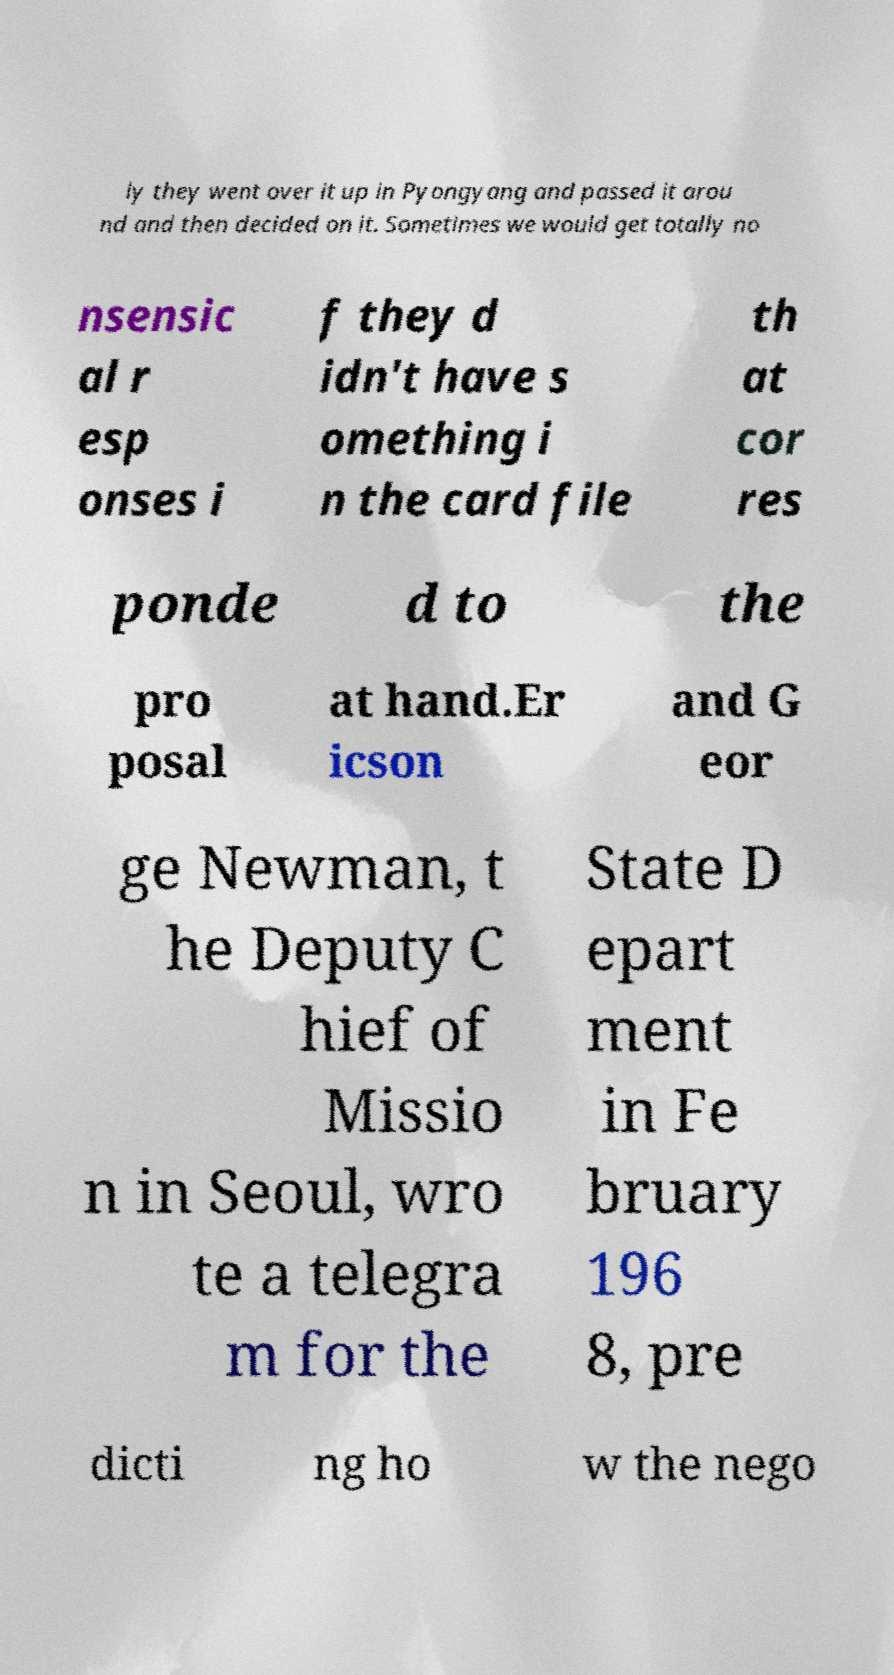There's text embedded in this image that I need extracted. Can you transcribe it verbatim? ly they went over it up in Pyongyang and passed it arou nd and then decided on it. Sometimes we would get totally no nsensic al r esp onses i f they d idn't have s omething i n the card file th at cor res ponde d to the pro posal at hand.Er icson and G eor ge Newman, t he Deputy C hief of Missio n in Seoul, wro te a telegra m for the State D epart ment in Fe bruary 196 8, pre dicti ng ho w the nego 